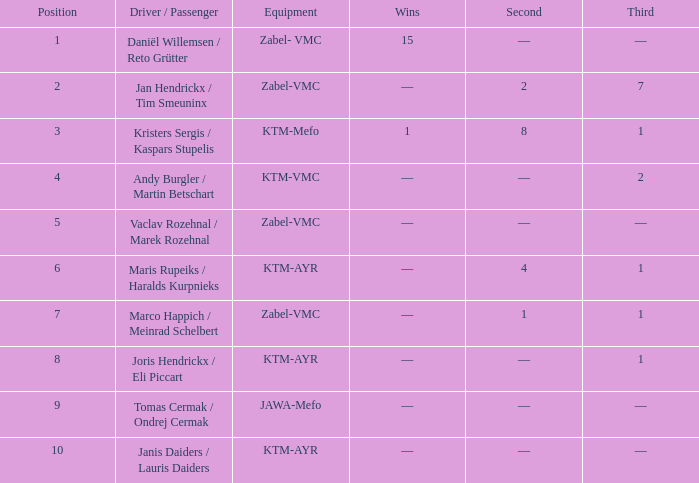Who was the driver/passengar when the position was smaller than 8, the third was 1, and there was 1 win? Kristers Sergis / Kaspars Stupelis. Could you help me parse every detail presented in this table? {'header': ['Position', 'Driver / Passenger', 'Equipment', 'Wins', 'Second', 'Third'], 'rows': [['1', 'Daniël Willemsen / Reto Grütter', 'Zabel- VMC', '15', '—', '—'], ['2', 'Jan Hendrickx / Tim Smeuninx', 'Zabel-VMC', '—', '2', '7'], ['3', 'Kristers Sergis / Kaspars Stupelis', 'KTM-Mefo', '1', '8', '1'], ['4', 'Andy Burgler / Martin Betschart', 'KTM-VMC', '—', '—', '2'], ['5', 'Vaclav Rozehnal / Marek Rozehnal', 'Zabel-VMC', '—', '—', '—'], ['6', 'Maris Rupeiks / Haralds Kurpnieks', 'KTM-AYR', '—', '4', '1'], ['7', 'Marco Happich / Meinrad Schelbert', 'Zabel-VMC', '—', '1', '1'], ['8', 'Joris Hendrickx / Eli Piccart', 'KTM-AYR', '—', '—', '1'], ['9', 'Tomas Cermak / Ondrej Cermak', 'JAWA-Mefo', '—', '—', '—'], ['10', 'Janis Daiders / Lauris Daiders', 'KTM-AYR', '—', '—', '—']]} 